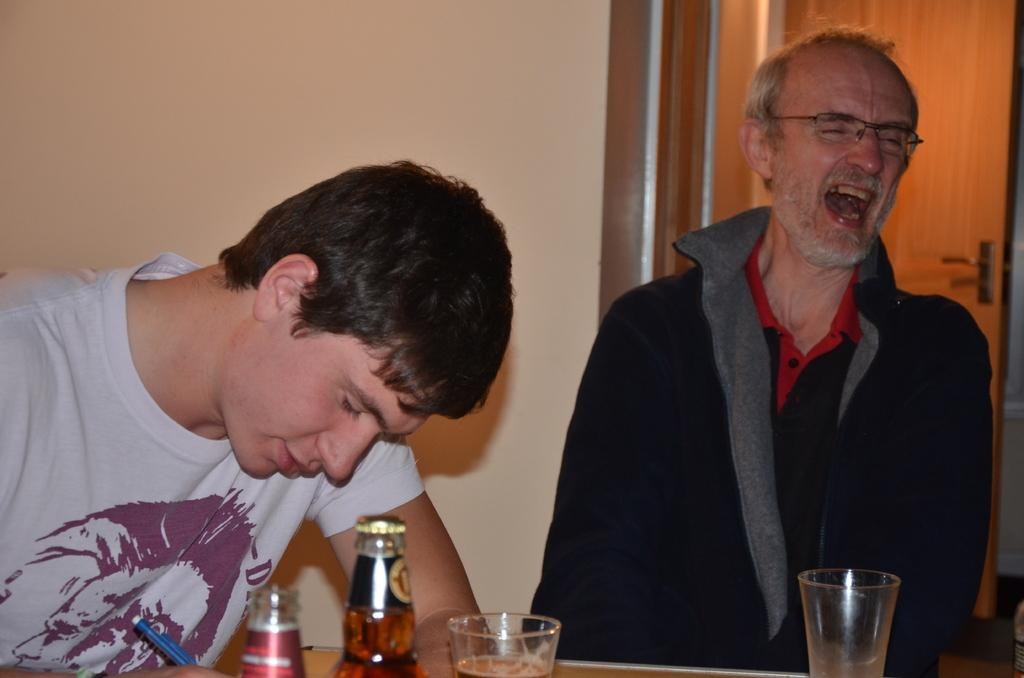Who are the people in the image? There is a boy and a man in the image. What are the boy and the man doing in the image? Both the boy and the man are sitting in front of a table. What items can be seen on the table? There are wine bottles and glasses on the table. What is visible in the background of the image? There is a door visible in the background. What type of bread can be seen on the railway tracks in the image? There is no railway or bread present in the image; it features a boy and a man sitting at a table with wine bottles and glasses. 